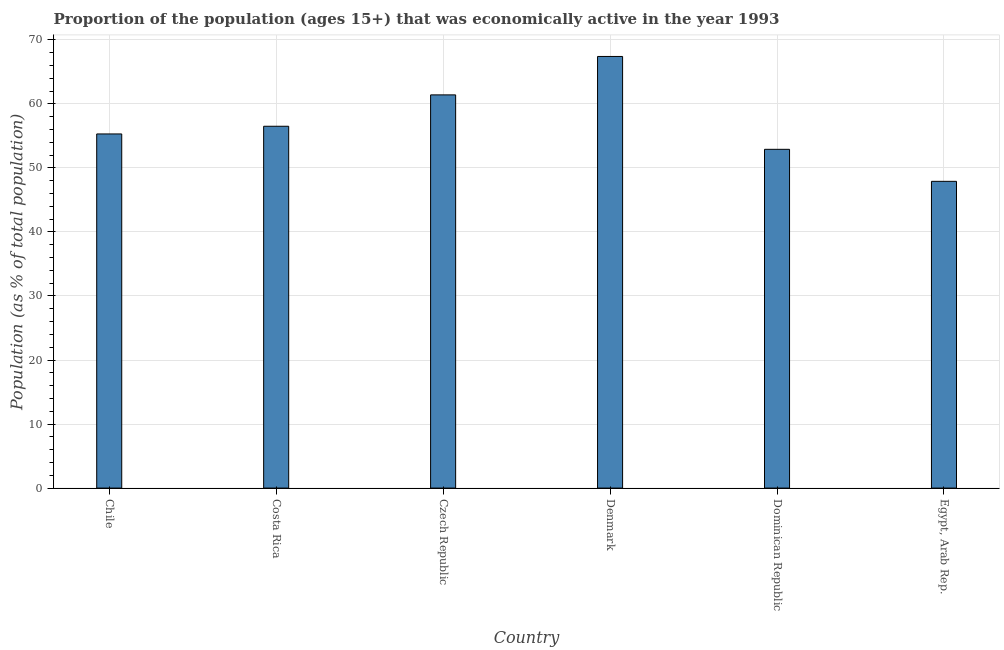What is the title of the graph?
Your answer should be very brief. Proportion of the population (ages 15+) that was economically active in the year 1993. What is the label or title of the Y-axis?
Your response must be concise. Population (as % of total population). What is the percentage of economically active population in Egypt, Arab Rep.?
Your answer should be compact. 47.9. Across all countries, what is the maximum percentage of economically active population?
Give a very brief answer. 67.4. Across all countries, what is the minimum percentage of economically active population?
Ensure brevity in your answer.  47.9. In which country was the percentage of economically active population minimum?
Your answer should be compact. Egypt, Arab Rep. What is the sum of the percentage of economically active population?
Your response must be concise. 341.4. What is the average percentage of economically active population per country?
Give a very brief answer. 56.9. What is the median percentage of economically active population?
Offer a terse response. 55.9. What is the ratio of the percentage of economically active population in Costa Rica to that in Dominican Republic?
Offer a terse response. 1.07. Is the difference between the percentage of economically active population in Costa Rica and Denmark greater than the difference between any two countries?
Provide a succinct answer. No. What is the difference between the highest and the lowest percentage of economically active population?
Your answer should be compact. 19.5. How many bars are there?
Offer a terse response. 6. What is the Population (as % of total population) of Chile?
Offer a terse response. 55.3. What is the Population (as % of total population) in Costa Rica?
Give a very brief answer. 56.5. What is the Population (as % of total population) of Czech Republic?
Make the answer very short. 61.4. What is the Population (as % of total population) of Denmark?
Offer a very short reply. 67.4. What is the Population (as % of total population) of Dominican Republic?
Keep it short and to the point. 52.9. What is the Population (as % of total population) in Egypt, Arab Rep.?
Keep it short and to the point. 47.9. What is the difference between the Population (as % of total population) in Chile and Czech Republic?
Ensure brevity in your answer.  -6.1. What is the difference between the Population (as % of total population) in Chile and Dominican Republic?
Your answer should be very brief. 2.4. What is the difference between the Population (as % of total population) in Costa Rica and Dominican Republic?
Offer a terse response. 3.6. What is the difference between the Population (as % of total population) in Czech Republic and Denmark?
Keep it short and to the point. -6. What is the difference between the Population (as % of total population) in Dominican Republic and Egypt, Arab Rep.?
Your answer should be compact. 5. What is the ratio of the Population (as % of total population) in Chile to that in Costa Rica?
Ensure brevity in your answer.  0.98. What is the ratio of the Population (as % of total population) in Chile to that in Czech Republic?
Keep it short and to the point. 0.9. What is the ratio of the Population (as % of total population) in Chile to that in Denmark?
Give a very brief answer. 0.82. What is the ratio of the Population (as % of total population) in Chile to that in Dominican Republic?
Make the answer very short. 1.04. What is the ratio of the Population (as % of total population) in Chile to that in Egypt, Arab Rep.?
Offer a very short reply. 1.15. What is the ratio of the Population (as % of total population) in Costa Rica to that in Denmark?
Offer a very short reply. 0.84. What is the ratio of the Population (as % of total population) in Costa Rica to that in Dominican Republic?
Provide a succinct answer. 1.07. What is the ratio of the Population (as % of total population) in Costa Rica to that in Egypt, Arab Rep.?
Provide a succinct answer. 1.18. What is the ratio of the Population (as % of total population) in Czech Republic to that in Denmark?
Ensure brevity in your answer.  0.91. What is the ratio of the Population (as % of total population) in Czech Republic to that in Dominican Republic?
Offer a terse response. 1.16. What is the ratio of the Population (as % of total population) in Czech Republic to that in Egypt, Arab Rep.?
Give a very brief answer. 1.28. What is the ratio of the Population (as % of total population) in Denmark to that in Dominican Republic?
Offer a very short reply. 1.27. What is the ratio of the Population (as % of total population) in Denmark to that in Egypt, Arab Rep.?
Your response must be concise. 1.41. What is the ratio of the Population (as % of total population) in Dominican Republic to that in Egypt, Arab Rep.?
Provide a short and direct response. 1.1. 